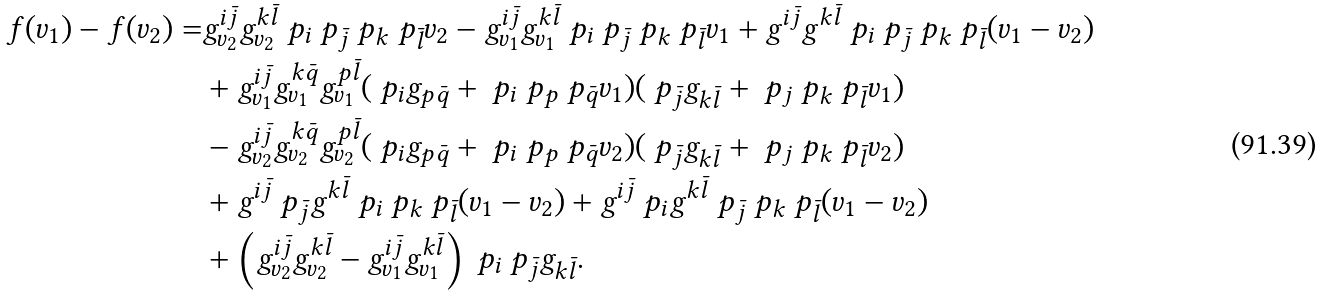Convert formula to latex. <formula><loc_0><loc_0><loc_500><loc_500>f ( v _ { 1 } ) - f ( v _ { 2 } ) = & g ^ { i \bar { j } } _ { v _ { 2 } } g ^ { k \bar { l } } _ { v _ { 2 } } \ p _ { i } \ p _ { \bar { j } } \ p _ { k } \ p _ { \bar { l } } v _ { 2 } - g ^ { i \bar { j } } _ { v _ { 1 } } g ^ { k \bar { l } } _ { v _ { 1 } } \ p _ { i } \ p _ { \bar { j } } \ p _ { k } \ p _ { \bar { l } } v _ { 1 } + g ^ { i \bar { j } } g ^ { k \bar { l } } \ p _ { i } \ p _ { \bar { j } } \ p _ { k } \ p _ { \bar { l } } ( v _ { 1 } - v _ { 2 } ) \\ & + g ^ { i \bar { j } } _ { v _ { 1 } } g ^ { k \bar { q } } _ { v _ { 1 } } g ^ { p \bar { l } } _ { v _ { 1 } } ( \ p _ { i } g _ { p \bar { q } } + \ p _ { i } \ p _ { p } \ p _ { \bar { q } } v _ { 1 } ) ( \ p _ { \bar { j } } g _ { k \bar { l } } + \ p _ { j } \ p _ { k } \ p _ { \bar { l } } v _ { 1 } ) \\ & - g ^ { i \bar { j } } _ { v _ { 2 } } g ^ { k \bar { q } } _ { v _ { 2 } } g ^ { p \bar { l } } _ { v _ { 2 } } ( \ p _ { i } g _ { p \bar { q } } + \ p _ { i } \ p _ { p } \ p _ { \bar { q } } v _ { 2 } ) ( \ p _ { \bar { j } } g _ { k \bar { l } } + \ p _ { j } \ p _ { k } \ p _ { \bar { l } } v _ { 2 } ) \\ & + g ^ { i \bar { j } } \ p _ { \bar { j } } g ^ { k \bar { l } } \ p _ { i } \ p _ { k } \ p _ { \bar { l } } ( v _ { 1 } - v _ { 2 } ) + g ^ { i \bar { j } } \ p _ { i } g ^ { k \bar { l } } \ p _ { \bar { j } } \ p _ { k } \ p _ { \bar { l } } ( v _ { 1 } - v _ { 2 } ) \\ & + \left ( g ^ { i \bar { j } } _ { v _ { 2 } } g ^ { k \bar { l } } _ { v _ { 2 } } - g ^ { i \bar { j } } _ { v _ { 1 } } g ^ { k \bar { l } } _ { v _ { 1 } } \right ) \ p _ { i } \ p _ { \bar { j } } g _ { k \bar { l } } .</formula> 